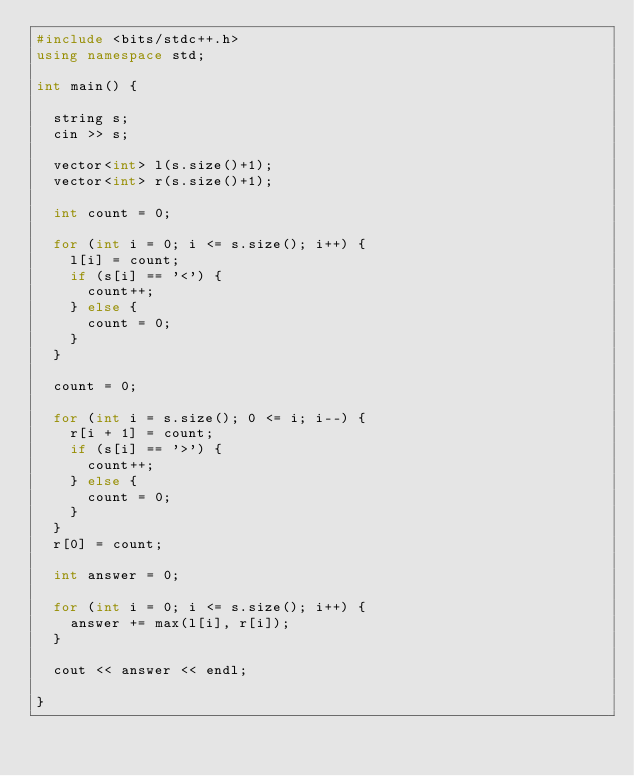Convert code to text. <code><loc_0><loc_0><loc_500><loc_500><_C++_>#include <bits/stdc++.h>
using namespace std;

int main() {

  string s;
  cin >> s;

  vector<int> l(s.size()+1);
  vector<int> r(s.size()+1);

  int count = 0;

  for (int i = 0; i <= s.size(); i++) {
    l[i] = count;
    if (s[i] == '<') {
      count++;
    } else {
      count = 0;
    }
  }

  count = 0;

  for (int i = s.size(); 0 <= i; i--) {
    r[i + 1] = count;
    if (s[i] == '>') {
      count++;
    } else {
      count = 0;
    }
  }
  r[0] = count;

  int answer = 0;

  for (int i = 0; i <= s.size(); i++) {
    answer += max(l[i], r[i]);
  }
  
  cout << answer << endl;
  
}</code> 